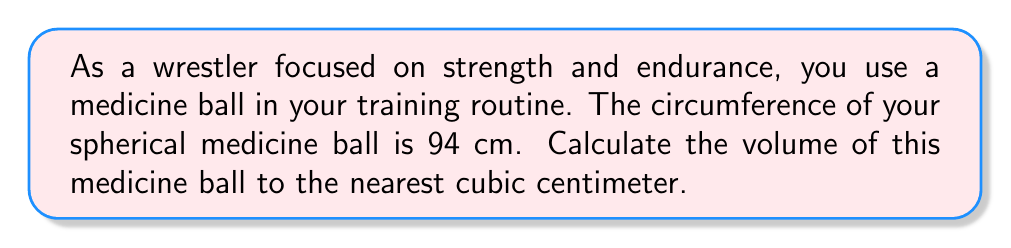Teach me how to tackle this problem. To solve this problem, we'll follow these steps:

1) First, we need to find the radius of the medicine ball. We can use the formula for the circumference of a sphere:

   $C = 2\pi r$

   Where $C$ is the circumference and $r$ is the radius.

2) We're given that $C = 94$ cm. Let's substitute this into our equation:

   $94 = 2\pi r$

3) Now, we can solve for $r$:

   $r = \frac{94}{2\pi} \approx 14.96$ cm

4) Now that we have the radius, we can use the formula for the volume of a sphere:

   $V = \frac{4}{3}\pi r^3$

5) Let's substitute our value for $r$:

   $V = \frac{4}{3}\pi (14.96)^3$

6) Now we can calculate:

   $V \approx 14,037.17$ cm³

7) Rounding to the nearest cubic centimeter:

   $V \approx 14,037$ cm³

This volume represents the amount of space your medicine ball occupies, which directly relates to the mass you're working with in your strength and endurance training.
Answer: $14,037$ cm³ 